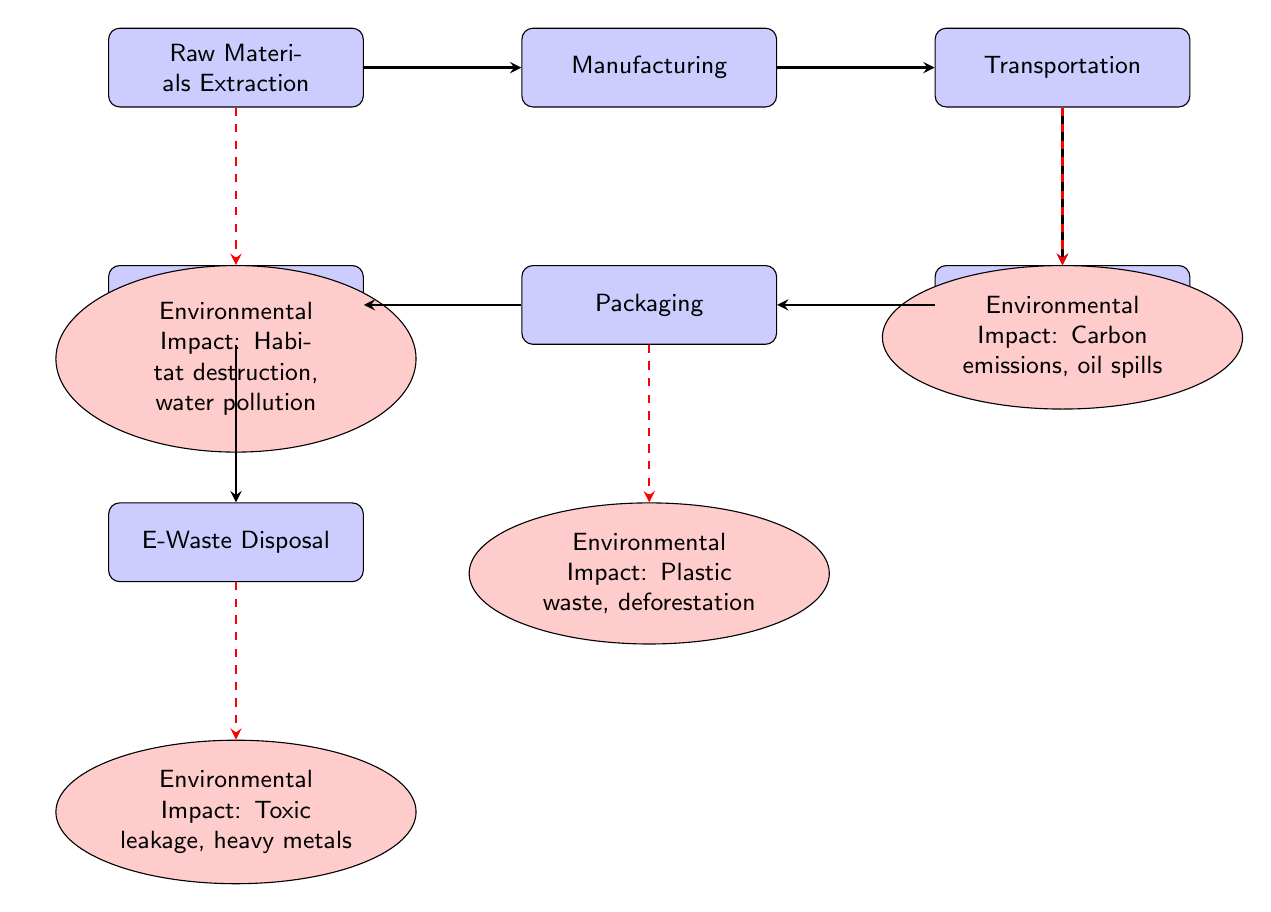What is the first process in the supply chain? The first process in the supply chain, as indicated by the leftmost node in the diagram, is "Raw Materials Extraction."
Answer: Raw Materials Extraction What type of environmental impact is associated with the Manufacturing process? The diagram shows that the Manufacturing process is not directly linked to any environmental impact, indicating that this step does not have a listed impact.
Answer: None How many distinct processes are shown in the supply chain? By counting the different rectangles in the diagram, we find there are six processes: Raw Materials Extraction, Manufacturing, Transportation, Warehouse Storage, Packaging, and Last Mile Delivery.
Answer: 6 What is the environmental impact associated with Last Mile Delivery? The diagram states that the Last Mile Delivery process leads to the impact of "Toxic leakage, heavy metals" as shown in the corresponding impact node located below this process.
Answer: Toxic leakage, heavy metals Which process has a direct connection to plastic waste? In the diagram, the process "Packaging" is linked to the environmental impact of "Plastic waste, deforestation," meaning this process has direct connections to plastic waste.
Answer: Packaging What type of waste is associated with the E-Waste Disposal process? The impact node linked from the E-Waste Disposal process indicates the environmental impact of "Toxic leakage, heavy metals," clearly defining the type of waste associated with it.
Answer: Toxic leakage, heavy metals Which process has the highest environmental impact listed among them? The diagram features environmental impacts such as habitat destruction, carbon emissions, plastic waste, and toxic leakage; however, the impact labeled for "Raw Materials Extraction" is broad, indicating habitat destruction—an impactful term in environmental discussions.
Answer: Habitat destruction What link connects Warehouse Storage to transportation in the supply chain? The link shown in the diagram connects from the Transportation process to the Warehouse Storage process, indicating that goods move from transportation to storage within the supply chain.
Answer: Transportation What is the relationship between Packaging and its environmental impact? The arrow from Packaging to the impact node indicates that this process is directly responsible for the environmental effects of "Plastic waste, deforestation," illustrating how certain business activities contribute directly to these environmental issues.
Answer: Direct responsibility 